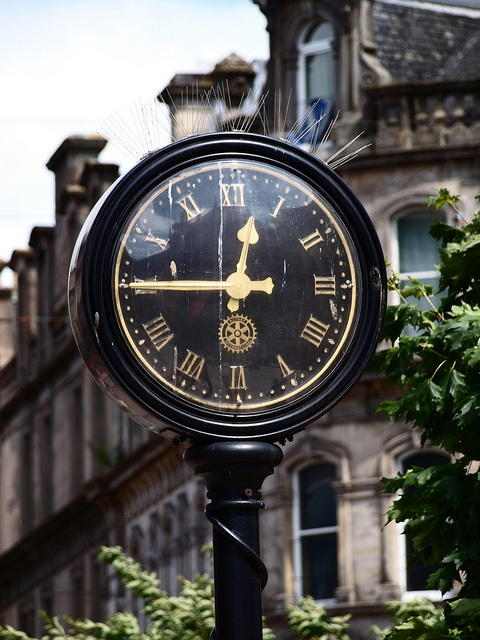Describe the objects in this image and their specific colors. I can see a clock in lavender, black, gray, darkgray, and tan tones in this image. 